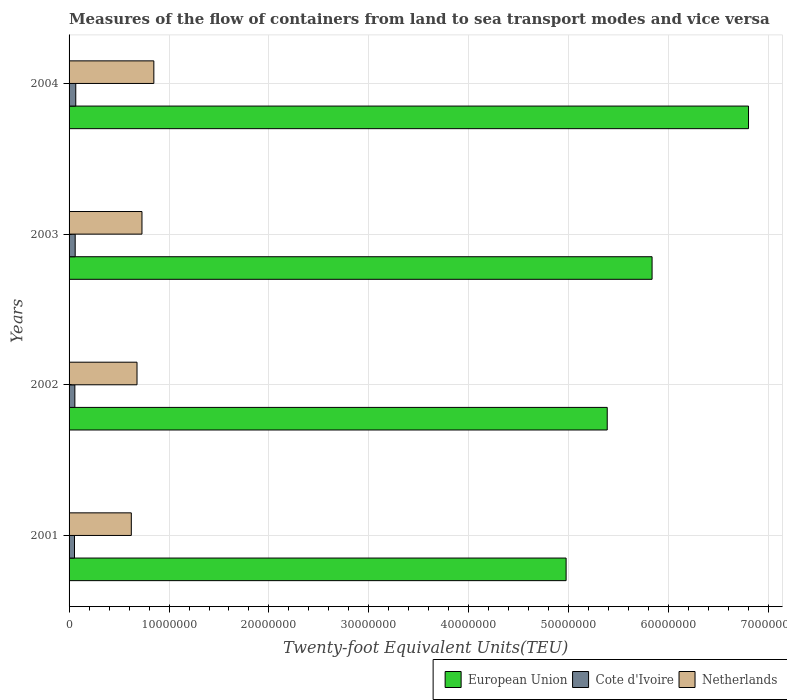How many different coloured bars are there?
Provide a short and direct response. 3. Are the number of bars on each tick of the Y-axis equal?
Provide a succinct answer. Yes. How many bars are there on the 1st tick from the top?
Keep it short and to the point. 3. How many bars are there on the 1st tick from the bottom?
Ensure brevity in your answer.  3. What is the label of the 1st group of bars from the top?
Your answer should be compact. 2004. What is the container port traffic in Netherlands in 2002?
Make the answer very short. 6.80e+06. Across all years, what is the maximum container port traffic in European Union?
Ensure brevity in your answer.  6.80e+07. Across all years, what is the minimum container port traffic in European Union?
Offer a terse response. 4.97e+07. In which year was the container port traffic in Netherlands minimum?
Keep it short and to the point. 2001. What is the total container port traffic in Cote d'Ivoire in the graph?
Your response must be concise. 2.41e+06. What is the difference between the container port traffic in European Union in 2003 and that in 2004?
Give a very brief answer. -9.65e+06. What is the difference between the container port traffic in Cote d'Ivoire in 2001 and the container port traffic in Netherlands in 2003?
Make the answer very short. -6.75e+06. What is the average container port traffic in Cote d'Ivoire per year?
Provide a short and direct response. 6.01e+05. In the year 2002, what is the difference between the container port traffic in Cote d'Ivoire and container port traffic in European Union?
Provide a short and direct response. -5.33e+07. In how many years, is the container port traffic in European Union greater than 36000000 TEU?
Keep it short and to the point. 4. What is the ratio of the container port traffic in Cote d'Ivoire in 2002 to that in 2004?
Offer a very short reply. 0.86. Is the container port traffic in Cote d'Ivoire in 2001 less than that in 2003?
Provide a short and direct response. Yes. Is the difference between the container port traffic in Cote d'Ivoire in 2001 and 2003 greater than the difference between the container port traffic in European Union in 2001 and 2003?
Your answer should be compact. Yes. What is the difference between the highest and the second highest container port traffic in European Union?
Give a very brief answer. 9.65e+06. What is the difference between the highest and the lowest container port traffic in Netherlands?
Offer a terse response. 2.25e+06. Is the sum of the container port traffic in Netherlands in 2002 and 2003 greater than the maximum container port traffic in Cote d'Ivoire across all years?
Offer a terse response. Yes. What does the 1st bar from the bottom in 2004 represents?
Offer a terse response. European Union. Does the graph contain any zero values?
Offer a very short reply. No. What is the title of the graph?
Give a very brief answer. Measures of the flow of containers from land to sea transport modes and vice versa. What is the label or title of the X-axis?
Provide a short and direct response. Twenty-foot Equivalent Units(TEU). What is the label or title of the Y-axis?
Provide a short and direct response. Years. What is the Twenty-foot Equivalent Units(TEU) in European Union in 2001?
Provide a short and direct response. 4.97e+07. What is the Twenty-foot Equivalent Units(TEU) of Cote d'Ivoire in 2001?
Your response must be concise. 5.44e+05. What is the Twenty-foot Equivalent Units(TEU) of Netherlands in 2001?
Your answer should be very brief. 6.23e+06. What is the Twenty-foot Equivalent Units(TEU) of European Union in 2002?
Make the answer very short. 5.38e+07. What is the Twenty-foot Equivalent Units(TEU) in Cote d'Ivoire in 2002?
Keep it short and to the point. 5.79e+05. What is the Twenty-foot Equivalent Units(TEU) in Netherlands in 2002?
Offer a terse response. 6.80e+06. What is the Twenty-foot Equivalent Units(TEU) of European Union in 2003?
Provide a succinct answer. 5.83e+07. What is the Twenty-foot Equivalent Units(TEU) of Cote d'Ivoire in 2003?
Keep it short and to the point. 6.13e+05. What is the Twenty-foot Equivalent Units(TEU) in Netherlands in 2003?
Provide a short and direct response. 7.29e+06. What is the Twenty-foot Equivalent Units(TEU) of European Union in 2004?
Your answer should be compact. 6.80e+07. What is the Twenty-foot Equivalent Units(TEU) of Cote d'Ivoire in 2004?
Ensure brevity in your answer.  6.70e+05. What is the Twenty-foot Equivalent Units(TEU) of Netherlands in 2004?
Offer a very short reply. 8.48e+06. Across all years, what is the maximum Twenty-foot Equivalent Units(TEU) in European Union?
Offer a terse response. 6.80e+07. Across all years, what is the maximum Twenty-foot Equivalent Units(TEU) of Cote d'Ivoire?
Provide a short and direct response. 6.70e+05. Across all years, what is the maximum Twenty-foot Equivalent Units(TEU) in Netherlands?
Your response must be concise. 8.48e+06. Across all years, what is the minimum Twenty-foot Equivalent Units(TEU) of European Union?
Your answer should be very brief. 4.97e+07. Across all years, what is the minimum Twenty-foot Equivalent Units(TEU) in Cote d'Ivoire?
Your response must be concise. 5.44e+05. Across all years, what is the minimum Twenty-foot Equivalent Units(TEU) of Netherlands?
Provide a succinct answer. 6.23e+06. What is the total Twenty-foot Equivalent Units(TEU) in European Union in the graph?
Offer a very short reply. 2.30e+08. What is the total Twenty-foot Equivalent Units(TEU) of Cote d'Ivoire in the graph?
Offer a very short reply. 2.41e+06. What is the total Twenty-foot Equivalent Units(TEU) of Netherlands in the graph?
Give a very brief answer. 2.88e+07. What is the difference between the Twenty-foot Equivalent Units(TEU) of European Union in 2001 and that in 2002?
Offer a terse response. -4.11e+06. What is the difference between the Twenty-foot Equivalent Units(TEU) of Cote d'Ivoire in 2001 and that in 2002?
Ensure brevity in your answer.  -3.52e+04. What is the difference between the Twenty-foot Equivalent Units(TEU) in Netherlands in 2001 and that in 2002?
Make the answer very short. -5.70e+05. What is the difference between the Twenty-foot Equivalent Units(TEU) of European Union in 2001 and that in 2003?
Provide a succinct answer. -8.60e+06. What is the difference between the Twenty-foot Equivalent Units(TEU) in Cote d'Ivoire in 2001 and that in 2003?
Provide a succinct answer. -6.87e+04. What is the difference between the Twenty-foot Equivalent Units(TEU) in Netherlands in 2001 and that in 2003?
Your response must be concise. -1.07e+06. What is the difference between the Twenty-foot Equivalent Units(TEU) in European Union in 2001 and that in 2004?
Your answer should be very brief. -1.83e+07. What is the difference between the Twenty-foot Equivalent Units(TEU) of Cote d'Ivoire in 2001 and that in 2004?
Your answer should be compact. -1.26e+05. What is the difference between the Twenty-foot Equivalent Units(TEU) of Netherlands in 2001 and that in 2004?
Provide a succinct answer. -2.25e+06. What is the difference between the Twenty-foot Equivalent Units(TEU) in European Union in 2002 and that in 2003?
Your answer should be very brief. -4.49e+06. What is the difference between the Twenty-foot Equivalent Units(TEU) in Cote d'Ivoire in 2002 and that in 2003?
Give a very brief answer. -3.35e+04. What is the difference between the Twenty-foot Equivalent Units(TEU) of Netherlands in 2002 and that in 2003?
Provide a short and direct response. -4.96e+05. What is the difference between the Twenty-foot Equivalent Units(TEU) in European Union in 2002 and that in 2004?
Keep it short and to the point. -1.41e+07. What is the difference between the Twenty-foot Equivalent Units(TEU) of Cote d'Ivoire in 2002 and that in 2004?
Your answer should be compact. -9.09e+04. What is the difference between the Twenty-foot Equivalent Units(TEU) in Netherlands in 2002 and that in 2004?
Give a very brief answer. -1.68e+06. What is the difference between the Twenty-foot Equivalent Units(TEU) in European Union in 2003 and that in 2004?
Make the answer very short. -9.65e+06. What is the difference between the Twenty-foot Equivalent Units(TEU) of Cote d'Ivoire in 2003 and that in 2004?
Your answer should be compact. -5.75e+04. What is the difference between the Twenty-foot Equivalent Units(TEU) of Netherlands in 2003 and that in 2004?
Give a very brief answer. -1.19e+06. What is the difference between the Twenty-foot Equivalent Units(TEU) in European Union in 2001 and the Twenty-foot Equivalent Units(TEU) in Cote d'Ivoire in 2002?
Your response must be concise. 4.92e+07. What is the difference between the Twenty-foot Equivalent Units(TEU) in European Union in 2001 and the Twenty-foot Equivalent Units(TEU) in Netherlands in 2002?
Provide a succinct answer. 4.29e+07. What is the difference between the Twenty-foot Equivalent Units(TEU) of Cote d'Ivoire in 2001 and the Twenty-foot Equivalent Units(TEU) of Netherlands in 2002?
Give a very brief answer. -6.25e+06. What is the difference between the Twenty-foot Equivalent Units(TEU) of European Union in 2001 and the Twenty-foot Equivalent Units(TEU) of Cote d'Ivoire in 2003?
Give a very brief answer. 4.91e+07. What is the difference between the Twenty-foot Equivalent Units(TEU) in European Union in 2001 and the Twenty-foot Equivalent Units(TEU) in Netherlands in 2003?
Offer a very short reply. 4.24e+07. What is the difference between the Twenty-foot Equivalent Units(TEU) of Cote d'Ivoire in 2001 and the Twenty-foot Equivalent Units(TEU) of Netherlands in 2003?
Ensure brevity in your answer.  -6.75e+06. What is the difference between the Twenty-foot Equivalent Units(TEU) of European Union in 2001 and the Twenty-foot Equivalent Units(TEU) of Cote d'Ivoire in 2004?
Make the answer very short. 4.91e+07. What is the difference between the Twenty-foot Equivalent Units(TEU) in European Union in 2001 and the Twenty-foot Equivalent Units(TEU) in Netherlands in 2004?
Make the answer very short. 4.12e+07. What is the difference between the Twenty-foot Equivalent Units(TEU) of Cote d'Ivoire in 2001 and the Twenty-foot Equivalent Units(TEU) of Netherlands in 2004?
Make the answer very short. -7.94e+06. What is the difference between the Twenty-foot Equivalent Units(TEU) of European Union in 2002 and the Twenty-foot Equivalent Units(TEU) of Cote d'Ivoire in 2003?
Offer a terse response. 5.32e+07. What is the difference between the Twenty-foot Equivalent Units(TEU) in European Union in 2002 and the Twenty-foot Equivalent Units(TEU) in Netherlands in 2003?
Give a very brief answer. 4.66e+07. What is the difference between the Twenty-foot Equivalent Units(TEU) of Cote d'Ivoire in 2002 and the Twenty-foot Equivalent Units(TEU) of Netherlands in 2003?
Offer a very short reply. -6.71e+06. What is the difference between the Twenty-foot Equivalent Units(TEU) in European Union in 2002 and the Twenty-foot Equivalent Units(TEU) in Cote d'Ivoire in 2004?
Your response must be concise. 5.32e+07. What is the difference between the Twenty-foot Equivalent Units(TEU) of European Union in 2002 and the Twenty-foot Equivalent Units(TEU) of Netherlands in 2004?
Offer a terse response. 4.54e+07. What is the difference between the Twenty-foot Equivalent Units(TEU) in Cote d'Ivoire in 2002 and the Twenty-foot Equivalent Units(TEU) in Netherlands in 2004?
Offer a very short reply. -7.90e+06. What is the difference between the Twenty-foot Equivalent Units(TEU) in European Union in 2003 and the Twenty-foot Equivalent Units(TEU) in Cote d'Ivoire in 2004?
Your answer should be very brief. 5.77e+07. What is the difference between the Twenty-foot Equivalent Units(TEU) of European Union in 2003 and the Twenty-foot Equivalent Units(TEU) of Netherlands in 2004?
Provide a short and direct response. 4.98e+07. What is the difference between the Twenty-foot Equivalent Units(TEU) in Cote d'Ivoire in 2003 and the Twenty-foot Equivalent Units(TEU) in Netherlands in 2004?
Your answer should be very brief. -7.87e+06. What is the average Twenty-foot Equivalent Units(TEU) in European Union per year?
Offer a very short reply. 5.75e+07. What is the average Twenty-foot Equivalent Units(TEU) in Cote d'Ivoire per year?
Give a very brief answer. 6.01e+05. What is the average Twenty-foot Equivalent Units(TEU) in Netherlands per year?
Your response must be concise. 7.20e+06. In the year 2001, what is the difference between the Twenty-foot Equivalent Units(TEU) of European Union and Twenty-foot Equivalent Units(TEU) of Cote d'Ivoire?
Offer a very short reply. 4.92e+07. In the year 2001, what is the difference between the Twenty-foot Equivalent Units(TEU) of European Union and Twenty-foot Equivalent Units(TEU) of Netherlands?
Offer a very short reply. 4.35e+07. In the year 2001, what is the difference between the Twenty-foot Equivalent Units(TEU) in Cote d'Ivoire and Twenty-foot Equivalent Units(TEU) in Netherlands?
Offer a very short reply. -5.68e+06. In the year 2002, what is the difference between the Twenty-foot Equivalent Units(TEU) of European Union and Twenty-foot Equivalent Units(TEU) of Cote d'Ivoire?
Keep it short and to the point. 5.33e+07. In the year 2002, what is the difference between the Twenty-foot Equivalent Units(TEU) of European Union and Twenty-foot Equivalent Units(TEU) of Netherlands?
Your answer should be very brief. 4.70e+07. In the year 2002, what is the difference between the Twenty-foot Equivalent Units(TEU) in Cote d'Ivoire and Twenty-foot Equivalent Units(TEU) in Netherlands?
Your response must be concise. -6.22e+06. In the year 2003, what is the difference between the Twenty-foot Equivalent Units(TEU) of European Union and Twenty-foot Equivalent Units(TEU) of Cote d'Ivoire?
Offer a very short reply. 5.77e+07. In the year 2003, what is the difference between the Twenty-foot Equivalent Units(TEU) in European Union and Twenty-foot Equivalent Units(TEU) in Netherlands?
Your answer should be very brief. 5.10e+07. In the year 2003, what is the difference between the Twenty-foot Equivalent Units(TEU) of Cote d'Ivoire and Twenty-foot Equivalent Units(TEU) of Netherlands?
Offer a very short reply. -6.68e+06. In the year 2004, what is the difference between the Twenty-foot Equivalent Units(TEU) of European Union and Twenty-foot Equivalent Units(TEU) of Cote d'Ivoire?
Offer a terse response. 6.73e+07. In the year 2004, what is the difference between the Twenty-foot Equivalent Units(TEU) in European Union and Twenty-foot Equivalent Units(TEU) in Netherlands?
Provide a succinct answer. 5.95e+07. In the year 2004, what is the difference between the Twenty-foot Equivalent Units(TEU) of Cote d'Ivoire and Twenty-foot Equivalent Units(TEU) of Netherlands?
Your answer should be compact. -7.81e+06. What is the ratio of the Twenty-foot Equivalent Units(TEU) in European Union in 2001 to that in 2002?
Keep it short and to the point. 0.92. What is the ratio of the Twenty-foot Equivalent Units(TEU) of Cote d'Ivoire in 2001 to that in 2002?
Provide a succinct answer. 0.94. What is the ratio of the Twenty-foot Equivalent Units(TEU) in Netherlands in 2001 to that in 2002?
Offer a terse response. 0.92. What is the ratio of the Twenty-foot Equivalent Units(TEU) of European Union in 2001 to that in 2003?
Your response must be concise. 0.85. What is the ratio of the Twenty-foot Equivalent Units(TEU) of Cote d'Ivoire in 2001 to that in 2003?
Give a very brief answer. 0.89. What is the ratio of the Twenty-foot Equivalent Units(TEU) in Netherlands in 2001 to that in 2003?
Give a very brief answer. 0.85. What is the ratio of the Twenty-foot Equivalent Units(TEU) of European Union in 2001 to that in 2004?
Your answer should be very brief. 0.73. What is the ratio of the Twenty-foot Equivalent Units(TEU) in Cote d'Ivoire in 2001 to that in 2004?
Provide a succinct answer. 0.81. What is the ratio of the Twenty-foot Equivalent Units(TEU) in Netherlands in 2001 to that in 2004?
Give a very brief answer. 0.73. What is the ratio of the Twenty-foot Equivalent Units(TEU) in Cote d'Ivoire in 2002 to that in 2003?
Ensure brevity in your answer.  0.95. What is the ratio of the Twenty-foot Equivalent Units(TEU) of Netherlands in 2002 to that in 2003?
Offer a terse response. 0.93. What is the ratio of the Twenty-foot Equivalent Units(TEU) of European Union in 2002 to that in 2004?
Ensure brevity in your answer.  0.79. What is the ratio of the Twenty-foot Equivalent Units(TEU) in Cote d'Ivoire in 2002 to that in 2004?
Provide a short and direct response. 0.86. What is the ratio of the Twenty-foot Equivalent Units(TEU) of Netherlands in 2002 to that in 2004?
Offer a terse response. 0.8. What is the ratio of the Twenty-foot Equivalent Units(TEU) of European Union in 2003 to that in 2004?
Your answer should be compact. 0.86. What is the ratio of the Twenty-foot Equivalent Units(TEU) of Cote d'Ivoire in 2003 to that in 2004?
Ensure brevity in your answer.  0.91. What is the ratio of the Twenty-foot Equivalent Units(TEU) of Netherlands in 2003 to that in 2004?
Provide a short and direct response. 0.86. What is the difference between the highest and the second highest Twenty-foot Equivalent Units(TEU) of European Union?
Give a very brief answer. 9.65e+06. What is the difference between the highest and the second highest Twenty-foot Equivalent Units(TEU) in Cote d'Ivoire?
Offer a terse response. 5.75e+04. What is the difference between the highest and the second highest Twenty-foot Equivalent Units(TEU) in Netherlands?
Keep it short and to the point. 1.19e+06. What is the difference between the highest and the lowest Twenty-foot Equivalent Units(TEU) of European Union?
Offer a very short reply. 1.83e+07. What is the difference between the highest and the lowest Twenty-foot Equivalent Units(TEU) of Cote d'Ivoire?
Give a very brief answer. 1.26e+05. What is the difference between the highest and the lowest Twenty-foot Equivalent Units(TEU) of Netherlands?
Keep it short and to the point. 2.25e+06. 